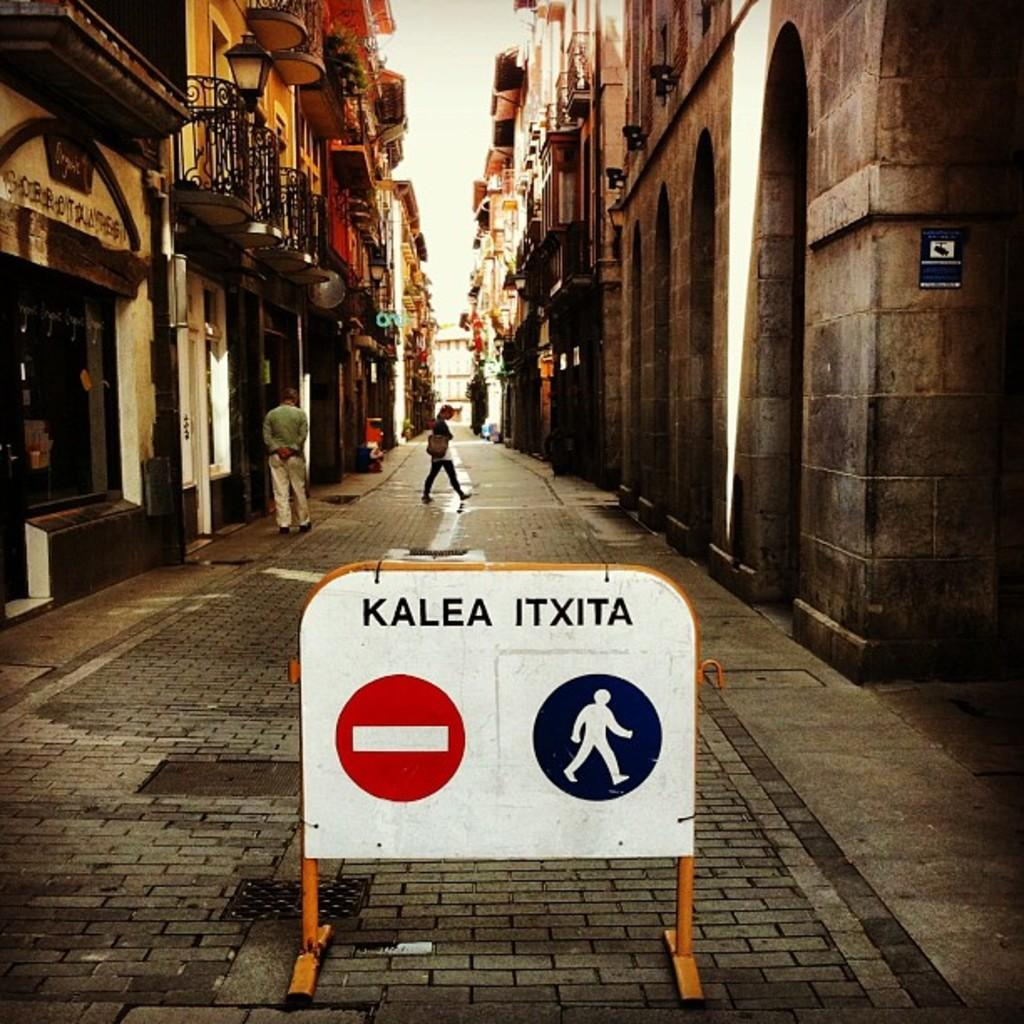<image>
Create a compact narrative representing the image presented. Sign in front of a street that says Kalea on one side and Itxita on the other. 